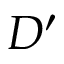<formula> <loc_0><loc_0><loc_500><loc_500>D ^ { \prime }</formula> 